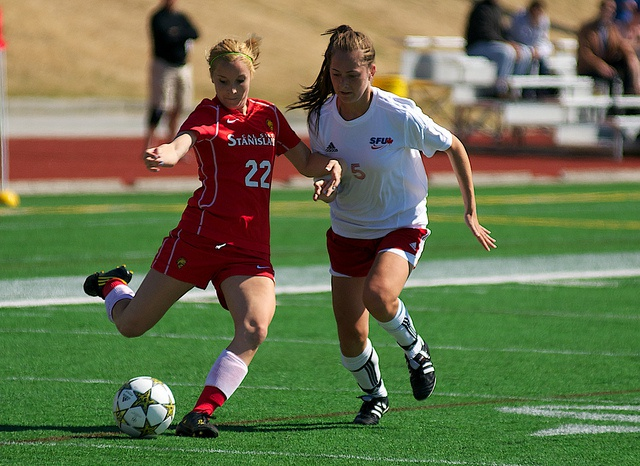Describe the objects in this image and their specific colors. I can see people in tan, maroon, black, and lightgray tones, people in tan, black, gray, and maroon tones, people in tan, black, gray, maroon, and brown tones, people in tan, black, gray, and maroon tones, and bench in tan, darkgray, lightgray, and gray tones in this image. 